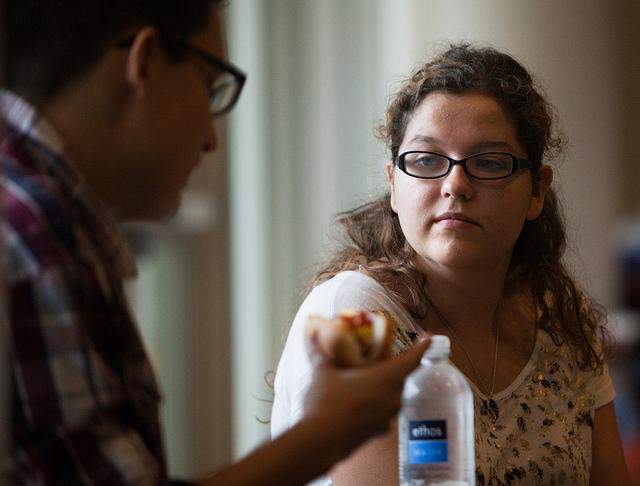Are these people drunk?
Answer briefly. No. How many pairs of glasses?
Keep it brief. 2. What color is her shirt?
Short answer required. White. What is the pattern of the man's shirt?
Short answer required. Plaid. Are the couple married?
Give a very brief answer. No. Is she pouring wine?
Quick response, please. No. Are these people at a party?
Quick response, please. No. 